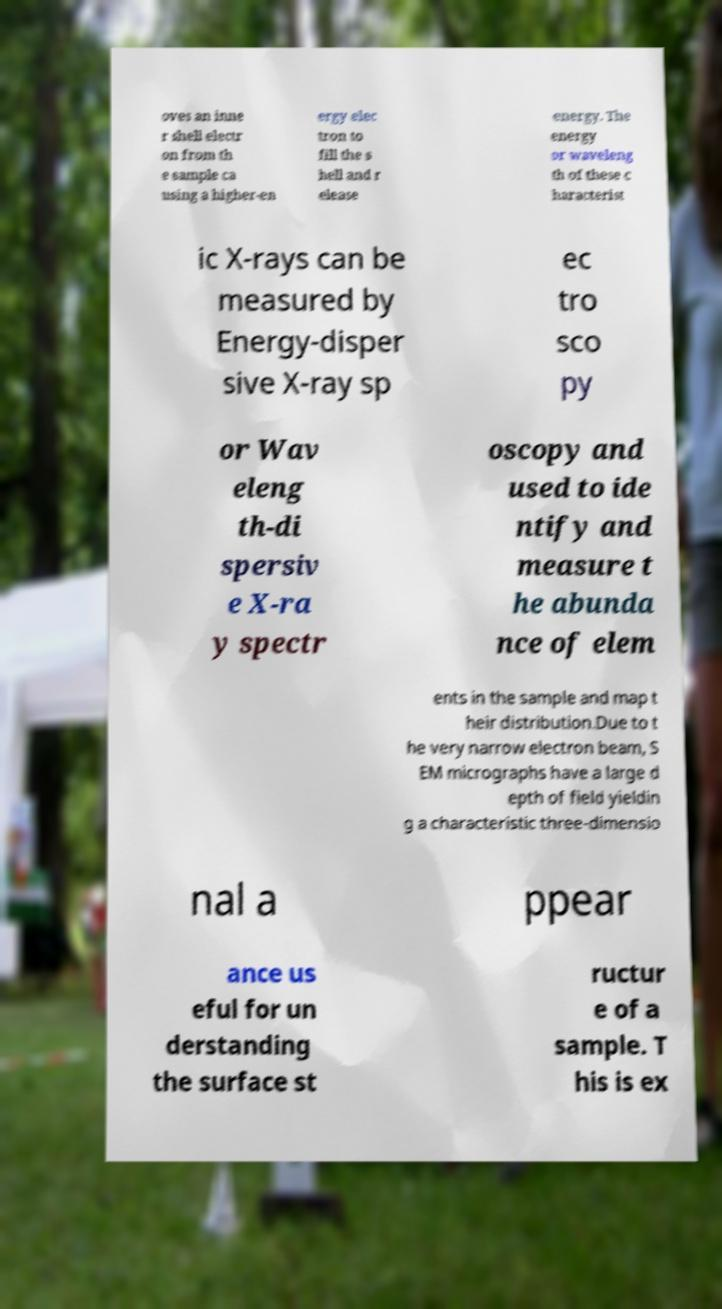There's text embedded in this image that I need extracted. Can you transcribe it verbatim? oves an inne r shell electr on from th e sample ca using a higher-en ergy elec tron to fill the s hell and r elease energy. The energy or waveleng th of these c haracterist ic X-rays can be measured by Energy-disper sive X-ray sp ec tro sco py or Wav eleng th-di spersiv e X-ra y spectr oscopy and used to ide ntify and measure t he abunda nce of elem ents in the sample and map t heir distribution.Due to t he very narrow electron beam, S EM micrographs have a large d epth of field yieldin g a characteristic three-dimensio nal a ppear ance us eful for un derstanding the surface st ructur e of a sample. T his is ex 